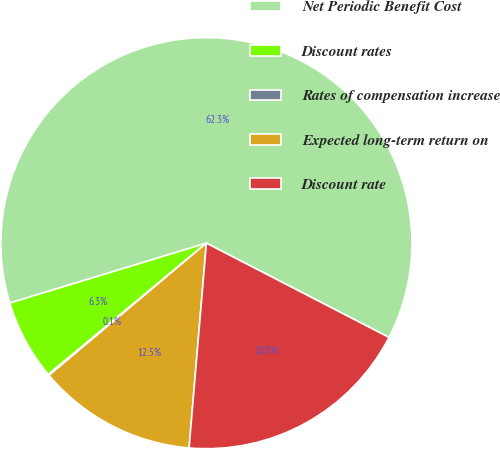Convert chart. <chart><loc_0><loc_0><loc_500><loc_500><pie_chart><fcel>Net Periodic Benefit Cost<fcel>Discount rates<fcel>Rates of compensation increase<fcel>Expected long-term return on<fcel>Discount rate<nl><fcel>62.3%<fcel>6.32%<fcel>0.09%<fcel>12.54%<fcel>18.76%<nl></chart> 